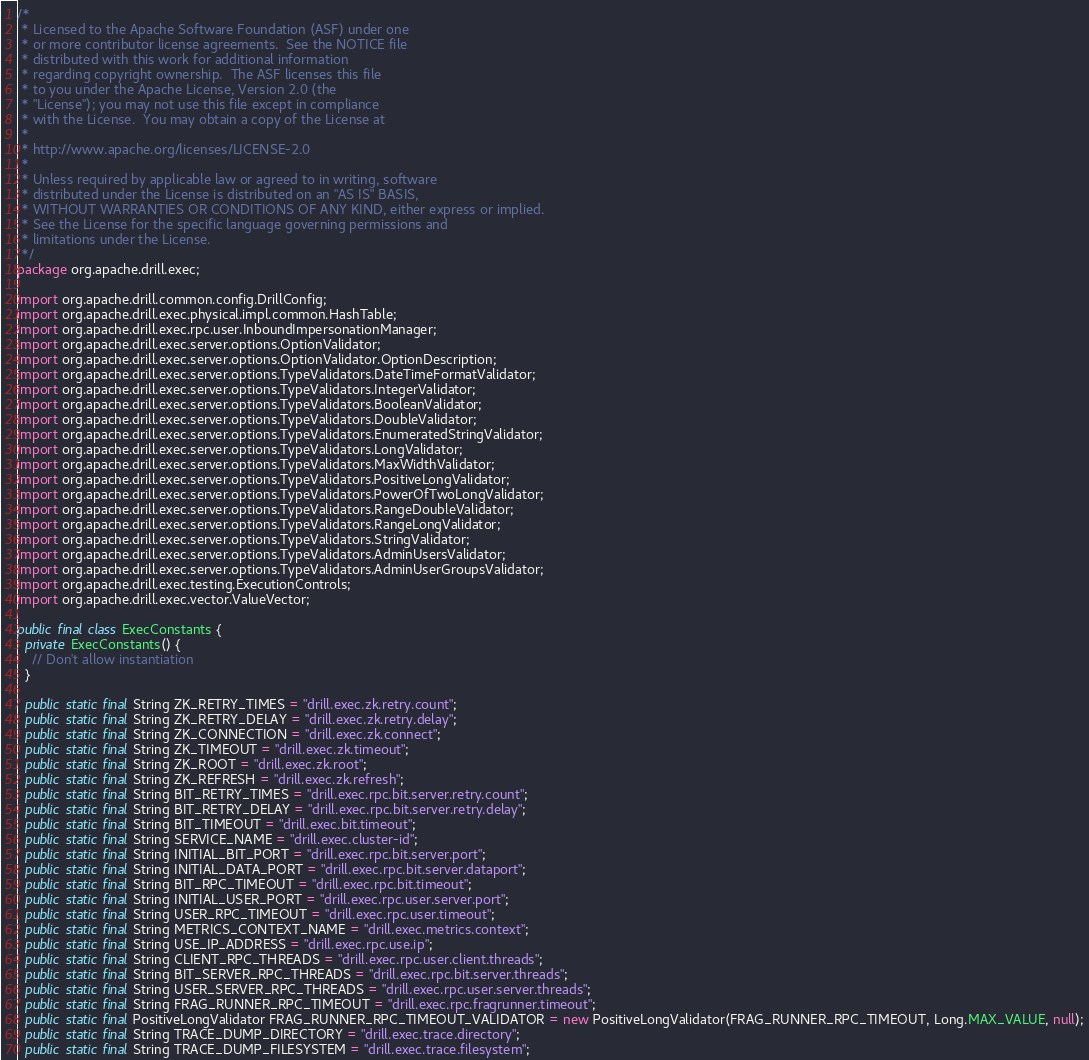Convert code to text. <code><loc_0><loc_0><loc_500><loc_500><_Java_>/*
 * Licensed to the Apache Software Foundation (ASF) under one
 * or more contributor license agreements.  See the NOTICE file
 * distributed with this work for additional information
 * regarding copyright ownership.  The ASF licenses this file
 * to you under the Apache License, Version 2.0 (the
 * "License"); you may not use this file except in compliance
 * with the License.  You may obtain a copy of the License at
 *
 * http://www.apache.org/licenses/LICENSE-2.0
 *
 * Unless required by applicable law or agreed to in writing, software
 * distributed under the License is distributed on an "AS IS" BASIS,
 * WITHOUT WARRANTIES OR CONDITIONS OF ANY KIND, either express or implied.
 * See the License for the specific language governing permissions and
 * limitations under the License.
 */
package org.apache.drill.exec;

import org.apache.drill.common.config.DrillConfig;
import org.apache.drill.exec.physical.impl.common.HashTable;
import org.apache.drill.exec.rpc.user.InboundImpersonationManager;
import org.apache.drill.exec.server.options.OptionValidator;
import org.apache.drill.exec.server.options.OptionValidator.OptionDescription;
import org.apache.drill.exec.server.options.TypeValidators.DateTimeFormatValidator;
import org.apache.drill.exec.server.options.TypeValidators.IntegerValidator;
import org.apache.drill.exec.server.options.TypeValidators.BooleanValidator;
import org.apache.drill.exec.server.options.TypeValidators.DoubleValidator;
import org.apache.drill.exec.server.options.TypeValidators.EnumeratedStringValidator;
import org.apache.drill.exec.server.options.TypeValidators.LongValidator;
import org.apache.drill.exec.server.options.TypeValidators.MaxWidthValidator;
import org.apache.drill.exec.server.options.TypeValidators.PositiveLongValidator;
import org.apache.drill.exec.server.options.TypeValidators.PowerOfTwoLongValidator;
import org.apache.drill.exec.server.options.TypeValidators.RangeDoubleValidator;
import org.apache.drill.exec.server.options.TypeValidators.RangeLongValidator;
import org.apache.drill.exec.server.options.TypeValidators.StringValidator;
import org.apache.drill.exec.server.options.TypeValidators.AdminUsersValidator;
import org.apache.drill.exec.server.options.TypeValidators.AdminUserGroupsValidator;
import org.apache.drill.exec.testing.ExecutionControls;
import org.apache.drill.exec.vector.ValueVector;

public final class ExecConstants {
  private ExecConstants() {
    // Don't allow instantiation
  }

  public static final String ZK_RETRY_TIMES = "drill.exec.zk.retry.count";
  public static final String ZK_RETRY_DELAY = "drill.exec.zk.retry.delay";
  public static final String ZK_CONNECTION = "drill.exec.zk.connect";
  public static final String ZK_TIMEOUT = "drill.exec.zk.timeout";
  public static final String ZK_ROOT = "drill.exec.zk.root";
  public static final String ZK_REFRESH = "drill.exec.zk.refresh";
  public static final String BIT_RETRY_TIMES = "drill.exec.rpc.bit.server.retry.count";
  public static final String BIT_RETRY_DELAY = "drill.exec.rpc.bit.server.retry.delay";
  public static final String BIT_TIMEOUT = "drill.exec.bit.timeout";
  public static final String SERVICE_NAME = "drill.exec.cluster-id";
  public static final String INITIAL_BIT_PORT = "drill.exec.rpc.bit.server.port";
  public static final String INITIAL_DATA_PORT = "drill.exec.rpc.bit.server.dataport";
  public static final String BIT_RPC_TIMEOUT = "drill.exec.rpc.bit.timeout";
  public static final String INITIAL_USER_PORT = "drill.exec.rpc.user.server.port";
  public static final String USER_RPC_TIMEOUT = "drill.exec.rpc.user.timeout";
  public static final String METRICS_CONTEXT_NAME = "drill.exec.metrics.context";
  public static final String USE_IP_ADDRESS = "drill.exec.rpc.use.ip";
  public static final String CLIENT_RPC_THREADS = "drill.exec.rpc.user.client.threads";
  public static final String BIT_SERVER_RPC_THREADS = "drill.exec.rpc.bit.server.threads";
  public static final String USER_SERVER_RPC_THREADS = "drill.exec.rpc.user.server.threads";
  public static final String FRAG_RUNNER_RPC_TIMEOUT = "drill.exec.rpc.fragrunner.timeout";
  public static final PositiveLongValidator FRAG_RUNNER_RPC_TIMEOUT_VALIDATOR = new PositiveLongValidator(FRAG_RUNNER_RPC_TIMEOUT, Long.MAX_VALUE, null);
  public static final String TRACE_DUMP_DIRECTORY = "drill.exec.trace.directory";
  public static final String TRACE_DUMP_FILESYSTEM = "drill.exec.trace.filesystem";</code> 